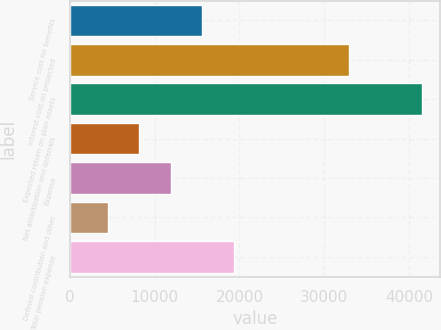Convert chart to OTSL. <chart><loc_0><loc_0><loc_500><loc_500><bar_chart><fcel>Service cost for benefits<fcel>Interest cost on projected<fcel>Expected return on plan assets<fcel>Net amortization and deferrals<fcel>Expense<fcel>Defined contribution and other<fcel>Total pension expense<nl><fcel>15592<fcel>32954<fcel>41569<fcel>8170<fcel>11881<fcel>4459<fcel>19303<nl></chart> 